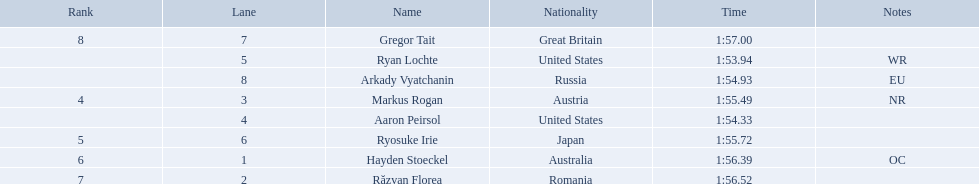Who are the swimmers? Ryan Lochte, Aaron Peirsol, Arkady Vyatchanin, Markus Rogan, Ryosuke Irie, Hayden Stoeckel, Răzvan Florea, Gregor Tait. What is ryosuke irie's time? 1:55.72. 